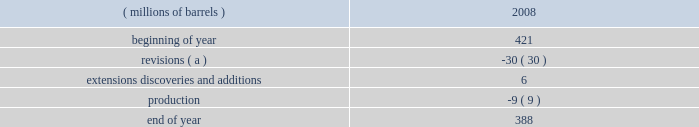Proved reserves can be added as expansions are permitted , funding is approved and certain stipulations of the joint venture agreement are satisfied .
The table sets forth changes in estimated quantities of net proved bitumen reserves for the year 2008 .
Estimated quantities of proved bitumen reserves ( millions of barrels ) 2008 .
( a ) revisions were driven primarily by price and the impact of the new royalty regime discussed below .
The above estimated quantity of net proved bitumen reserves is a forward-looking statement and is based on a number of assumptions , including ( among others ) commodity prices , volumes in-place , presently known physical data , recoverability of bitumen , industry economic conditions , levels of cash flow from operations , and other operating considerations .
To the extent these assumptions prove inaccurate , actual recoveries could be different than current estimates .
For a discussion of the proved bitumen reserves estimation process , see item 7 .
Management 2019s discussion and analysis of financial condition and results of operations 2013 critical accounting estimates 2013 estimated net recoverable reserve quantities 2013 proved bitumen reserves .
Operations at the aosp are not within the scope of statement of financial accounting standards ( 201csfas 201d ) no .
25 , 201csuspension of certain accounting requirements for oil and gas producing companies ( an amendment of financial accounting standards board ( 201cfasb 201d ) statement no .
19 ) , 201d sfas no .
69 , 201cdisclosures about oil and gas producing activities ( an amendment of fasb statements 19 , 25 , 33 and 39 ) , 201d and securities and exchange commission ( 201csec 201d ) rule 4-10 of regulation s-x ; therefore , bitumen production and reserves are not included in our supplementary information on oil and gas producing activities .
The sec has recently issued a release amending these disclosure requirements effective for annual reports on form 10-k for fiscal years ending on or after december 31 , 2009 , see item 7 .
Management 2019s discussion and analysis of financial condition and results of operations 2013 accounting standards not yet adopted for additional information .
Prior to our acquisition of western , the first fully-integrated expansion of the existing aosp facilities was approved in 2006 .
Expansion 1 , which includes construction of mining and extraction facilities at the jackpine mine , expansion of treatment facilities at the existing muskeg river mine , expansion of the scotford upgrader and development of related infrastructure , is anticipated to begin operations in late 2010 or 2011 .
When expansion 1 is complete , we will have more than 50000 bpd of net production and upgrading capacity in the canadian oil sands .
The timing and scope of future expansions and debottlenecking opportunities on existing operations remain under review .
During 2008 , the alberta government accepted the project 2019s application to have a portion of the expansion 1 capital costs form part of the muskeg river mine 2019s allowable cost recovery pool .
Due to commodity price declines in the year , royalties for 2008 were one percent of the gross mine revenue .
Commencing january 1 , 2009 , the alberta royalty regime has been amended such that royalty rates will be based on the canadian dollar ( 201ccad 201d ) equivalent monthly average west texas intermediate ( 201cwti 201d ) price .
Royalty rates will rise from a minimum of one percent to a maximum of nine percent under the gross revenue method and from a minimum of 25 percent to a maximum of 40 percent under the net revenue method .
Under both methods , the minimum royalty is based on a wti price of $ 55.00 cad per barrel and below while the maximum royalty is reached at a wti price of $ 120.00 cad per barrel and above , with a linear increase in royalty between the aforementioned prices .
The above discussion of the oil sands mining segment includes forward-looking statements concerning the anticipated completion of aosp expansion 1 .
Factors which could affect the expansion project include transportation logistics , availability of materials and labor , unforeseen hazards such as weather conditions , delays in obtaining or conditions imposed by necessary government and third-party approvals and other risks customarily associated with construction projects .
Refining , marketing and transportation refining we own and operate seven refineries in the gulf coast , midwest and upper great plains regions of the united states with an aggregate refining capacity of 1.016 million barrels per day ( 201cmmbpd 201d ) of crude oil .
During 2008 .
By how much did proved bitumen reserves decrease during 2008? 
Computations: ((388 - 421) / 421)
Answer: -0.07838. 